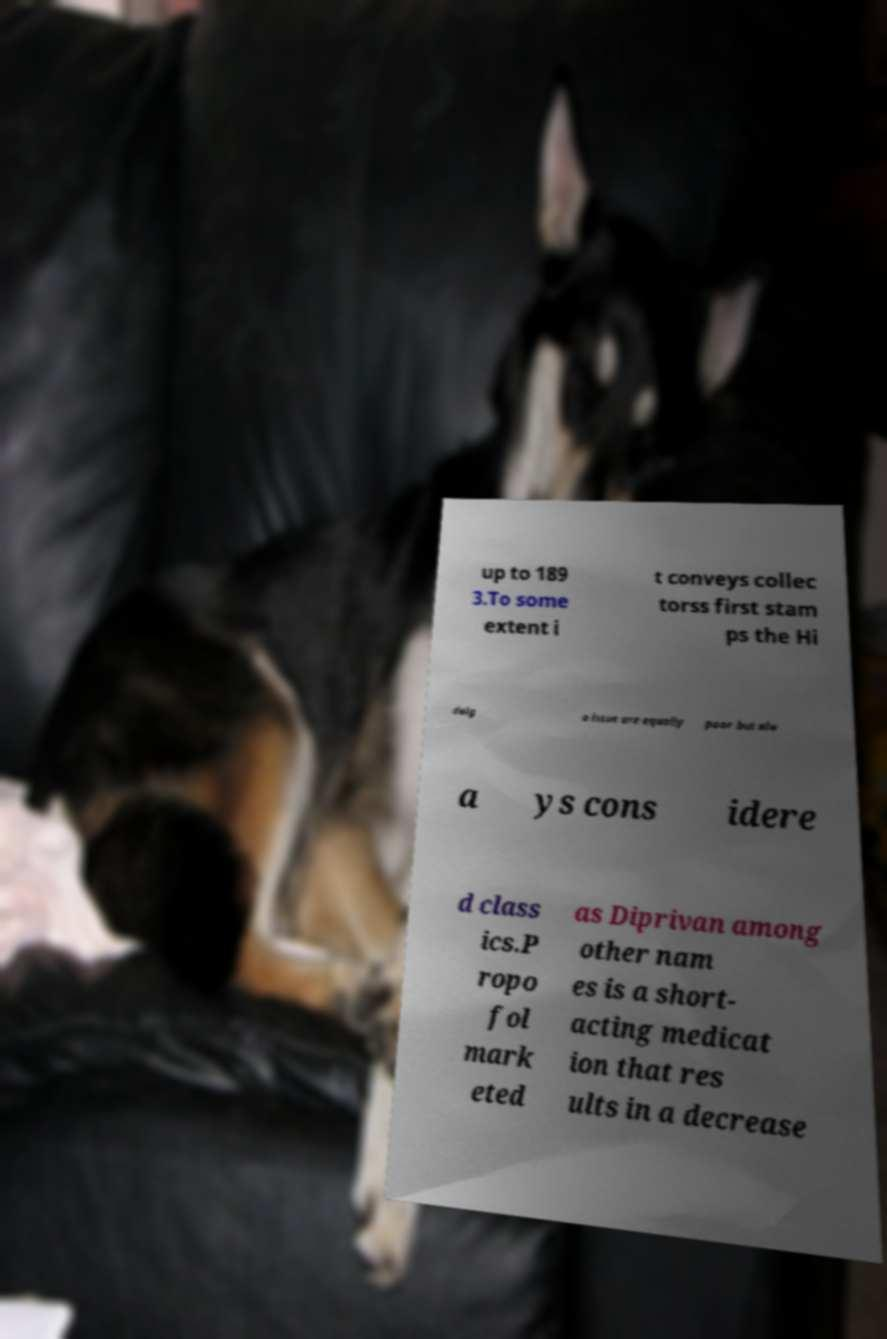For documentation purposes, I need the text within this image transcribed. Could you provide that? up to 189 3.To some extent i t conveys collec torss first stam ps the Hi dalg o issue are equally poor but alw a ys cons idere d class ics.P ropo fol mark eted as Diprivan among other nam es is a short- acting medicat ion that res ults in a decrease 